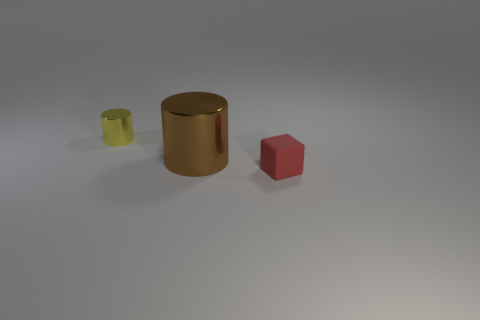There is a small thing that is behind the red block; how many small cylinders are on the right side of it?
Offer a terse response. 0. How many small things have the same material as the large thing?
Give a very brief answer. 1. Are there any large brown metallic cylinders behind the red rubber cube?
Offer a very short reply. Yes. What color is the shiny object that is the same size as the cube?
Make the answer very short. Yellow. How many objects are tiny red things in front of the tiny shiny cylinder or tiny metal cylinders?
Provide a short and direct response. 2. There is a thing that is to the left of the matte cube and in front of the small cylinder; what size is it?
Make the answer very short. Large. How many other objects are the same size as the brown thing?
Make the answer very short. 0. There is a small thing that is in front of the tiny yellow object that is left of the cylinder that is on the right side of the tiny shiny object; what is its color?
Provide a succinct answer. Red. There is a object that is both behind the tiny rubber block and on the right side of the yellow metallic object; what is its shape?
Keep it short and to the point. Cylinder. What number of other things are there of the same shape as the yellow metal thing?
Make the answer very short. 1. 